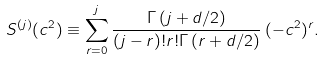Convert formula to latex. <formula><loc_0><loc_0><loc_500><loc_500>S ^ { ( j ) } ( c ^ { 2 } ) \equiv \sum _ { r = 0 } ^ { j } \frac { \Gamma \left ( j + d / 2 \right ) } { ( j - r ) ! r ! \Gamma \left ( r + d / 2 \right ) } \, ( - c ^ { 2 } ) ^ { r } .</formula> 